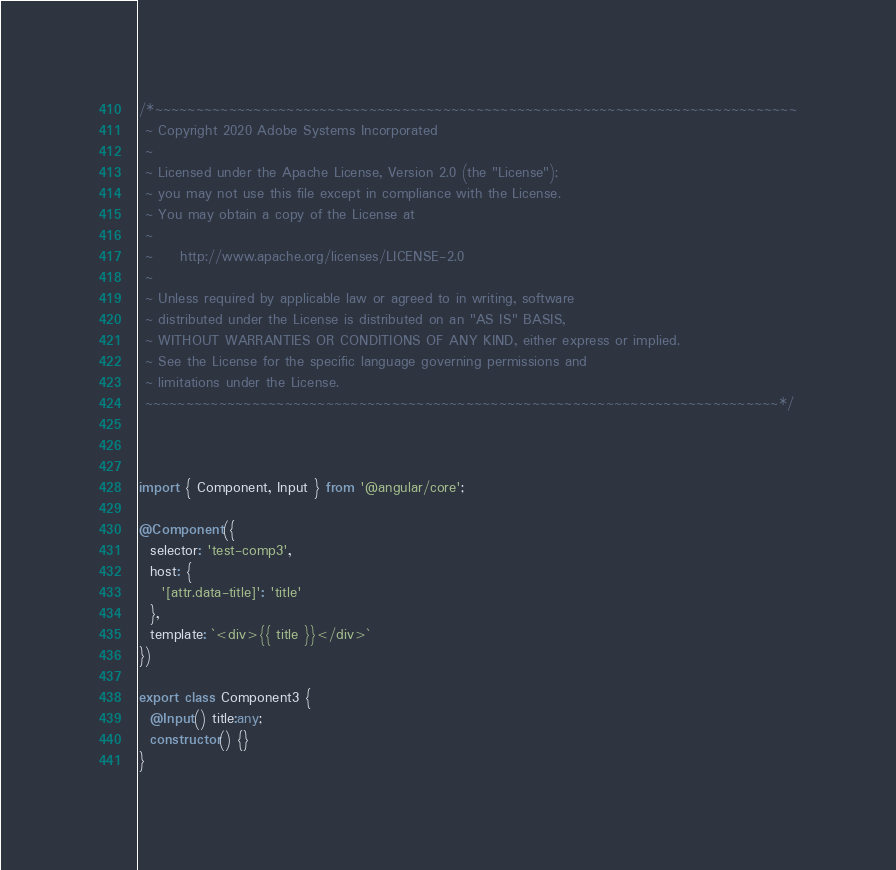Convert code to text. <code><loc_0><loc_0><loc_500><loc_500><_TypeScript_>/*~~~~~~~~~~~~~~~~~~~~~~~~~~~~~~~~~~~~~~~~~~~~~~~~~~~~~~~~~~~~~~~~~~~~~~~~~~~~~~
 ~ Copyright 2020 Adobe Systems Incorporated
 ~
 ~ Licensed under the Apache License, Version 2.0 (the "License");
 ~ you may not use this file except in compliance with the License.
 ~ You may obtain a copy of the License at
 ~
 ~     http://www.apache.org/licenses/LICENSE-2.0
 ~
 ~ Unless required by applicable law or agreed to in writing, software
 ~ distributed under the License is distributed on an "AS IS" BASIS,
 ~ WITHOUT WARRANTIES OR CONDITIONS OF ANY KIND, either express or implied.
 ~ See the License for the specific language governing permissions and
 ~ limitations under the License.
 ~~~~~~~~~~~~~~~~~~~~~~~~~~~~~~~~~~~~~~~~~~~~~~~~~~~~~~~~~~~~~~~~~~~~~~~~~~~~~*/



import { Component, Input } from '@angular/core';

@Component({
  selector: 'test-comp3',
  host: {
    '[attr.data-title]': 'title'
  },
  template: `<div>{{ title }}</div>`
})

export class Component3 {
  @Input() title:any;
  constructor() {}
}
</code> 